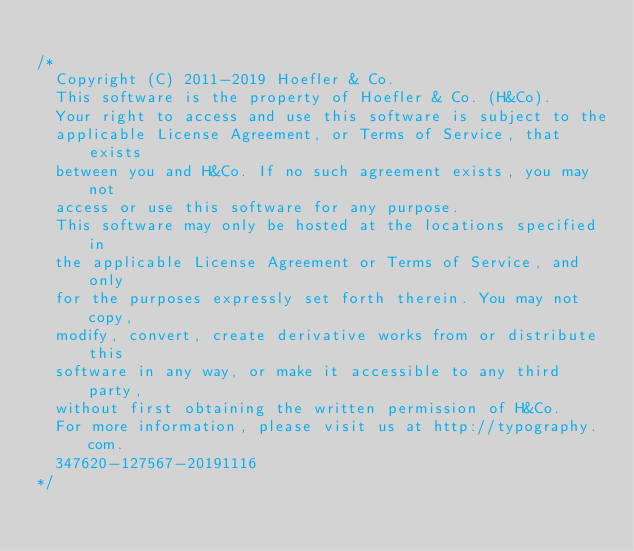Convert code to text. <code><loc_0><loc_0><loc_500><loc_500><_CSS_>
/*
	Copyright (C) 2011-2019 Hoefler & Co.
	This software is the property of Hoefler & Co. (H&Co).
	Your right to access and use this software is subject to the
	applicable License Agreement, or Terms of Service, that exists
	between you and H&Co. If no such agreement exists, you may not
	access or use this software for any purpose.
	This software may only be hosted at the locations specified in
	the applicable License Agreement or Terms of Service, and only
	for the purposes expressly set forth therein. You may not copy,
	modify, convert, create derivative works from or distribute this
	software in any way, or make it accessible to any third party,
	without first obtaining the written permission of H&Co.
	For more information, please visit us at http://typography.com.
	347620-127567-20191116
*/
</code> 